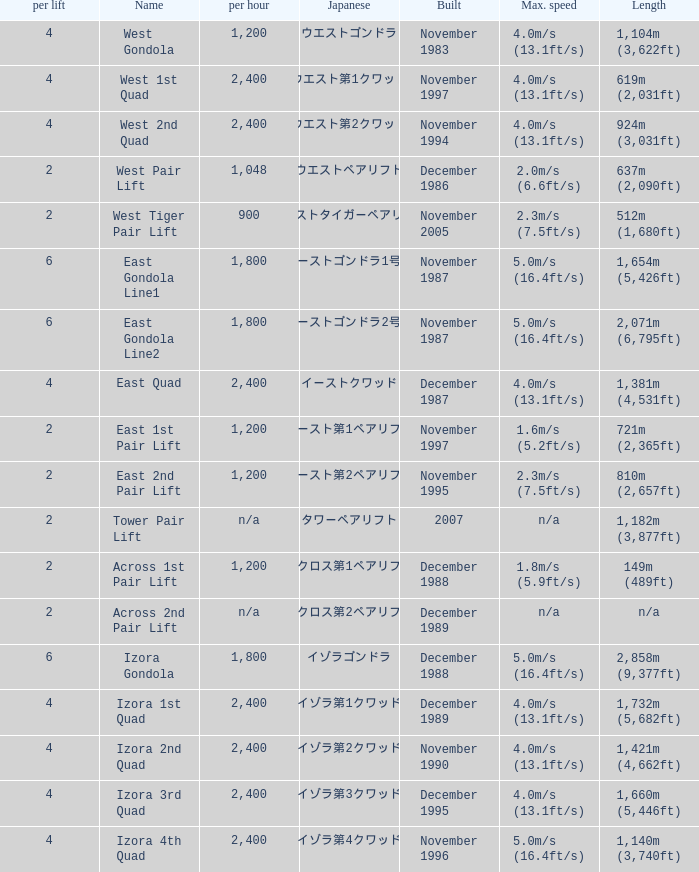How heavy is the  maximum 6.0. 